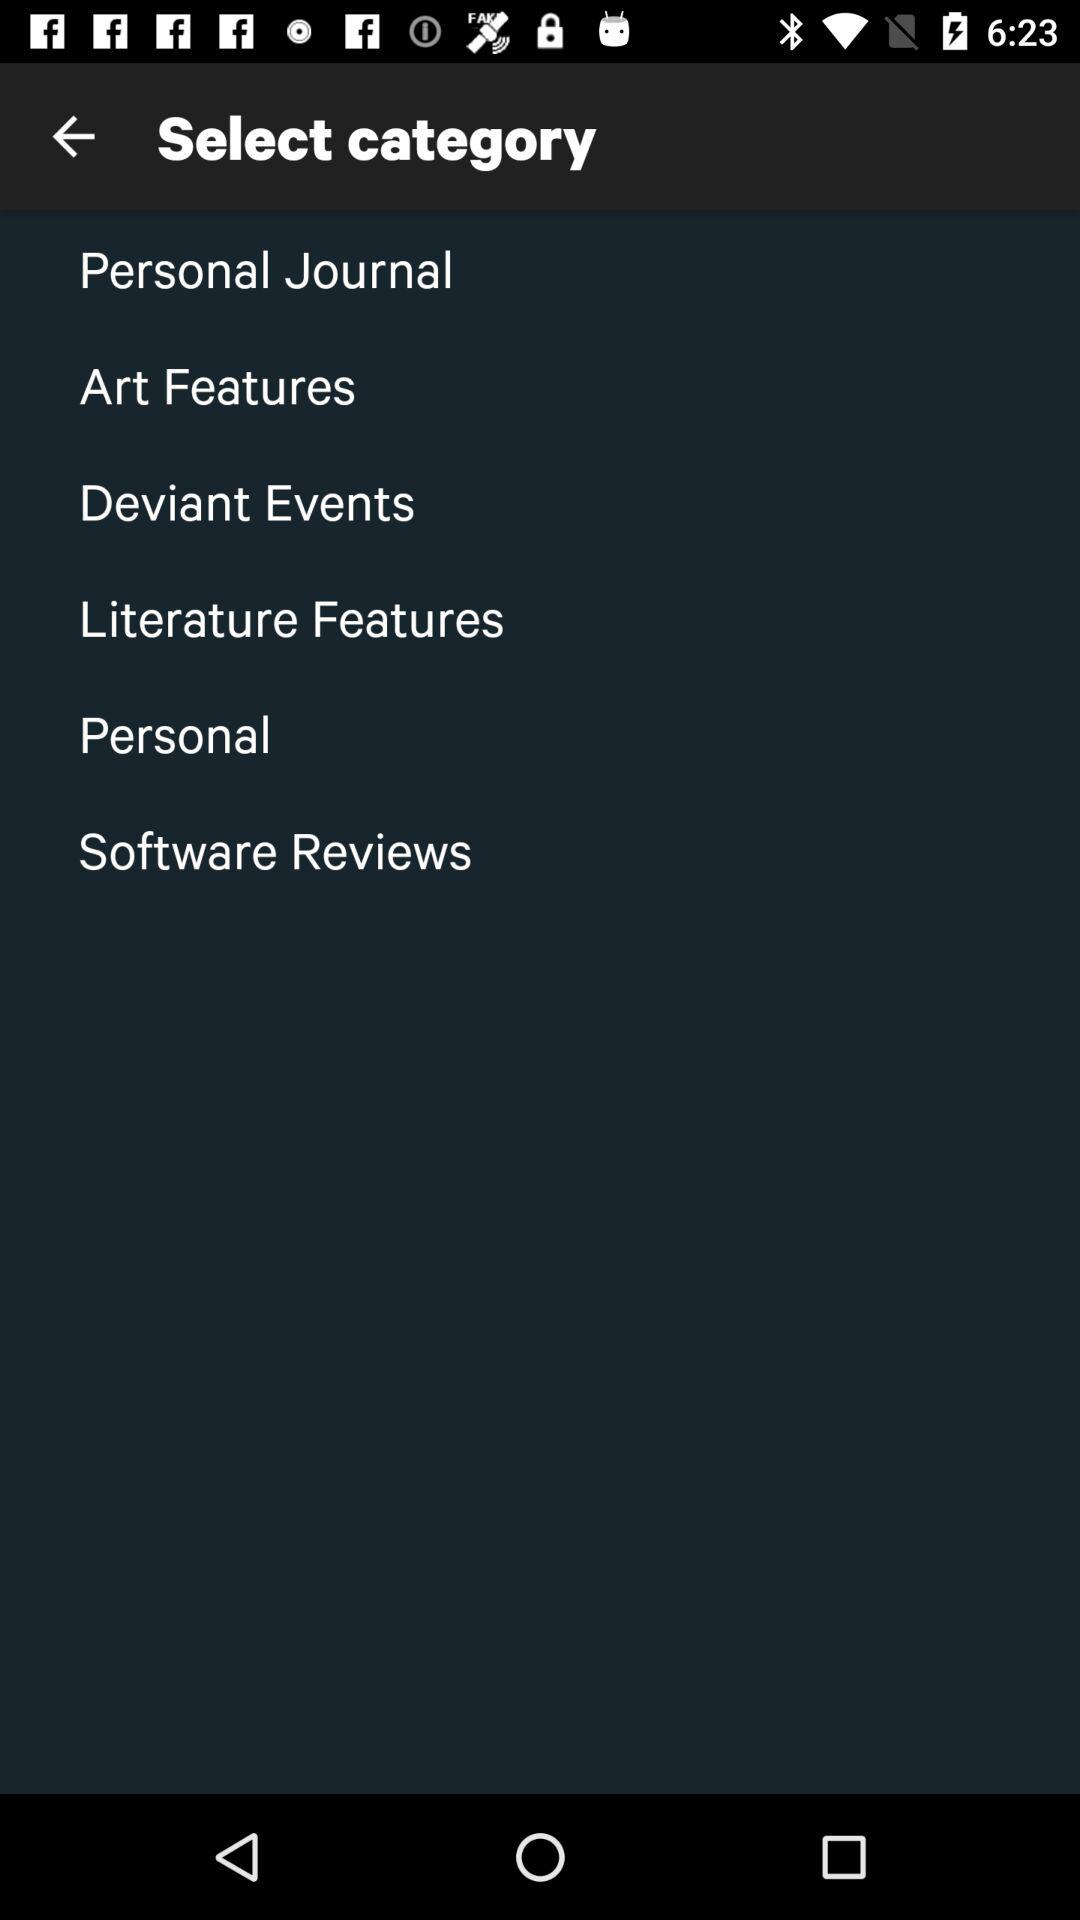How many categories are there in total?
Answer the question using a single word or phrase. 6 